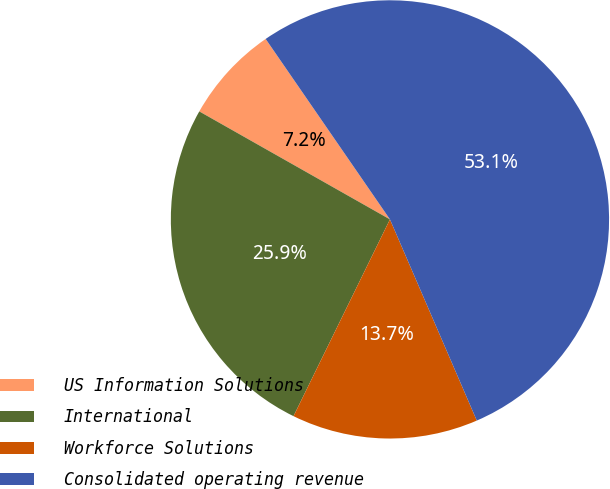Convert chart. <chart><loc_0><loc_0><loc_500><loc_500><pie_chart><fcel>US Information Solutions<fcel>International<fcel>Workforce Solutions<fcel>Consolidated operating revenue<nl><fcel>7.2%<fcel>25.95%<fcel>13.74%<fcel>53.12%<nl></chart> 